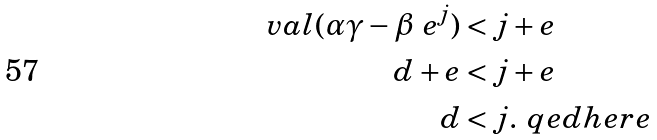<formula> <loc_0><loc_0><loc_500><loc_500>\ v a l ( \alpha \gamma - \beta \ e ^ { j } ) & < j + e \\ d + e & < j + e \\ d & < j . \ q e d h e r e</formula> 